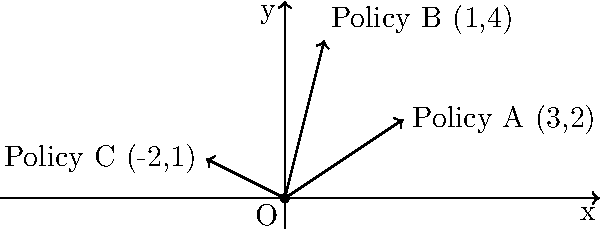In a policy analysis scenario, three different policy influences are represented as vectors on a coordinate plane. Policy A is represented by the vector (3,2), Policy B by (1,4), and Policy C by (-2,1). Calculate the resultant vector of these three policy influences combined. What is the magnitude of this resultant vector, rounded to two decimal places? To find the resultant vector and its magnitude, we'll follow these steps:

1) First, we need to add the three vectors:
   Resultant = A + B + C
   = (3,2) + (1,4) + (-2,1)
   
2) Add the x-components:
   x = 3 + 1 + (-2) = 2
   
3) Add the y-components:
   y = 2 + 4 + 1 = 7
   
4) The resultant vector is therefore (2,7)

5) To find the magnitude of this vector, we use the Pythagorean theorem:
   Magnitude = $\sqrt{x^2 + y^2}$
   
6) Substituting our values:
   Magnitude = $\sqrt{2^2 + 7^2}$
             = $\sqrt{4 + 49}$
             = $\sqrt{53}$
             
7) Using a calculator and rounding to two decimal places:
   $\sqrt{53}$ ≈ 7.28

Therefore, the magnitude of the resultant vector is approximately 7.28 units.
Answer: 7.28 